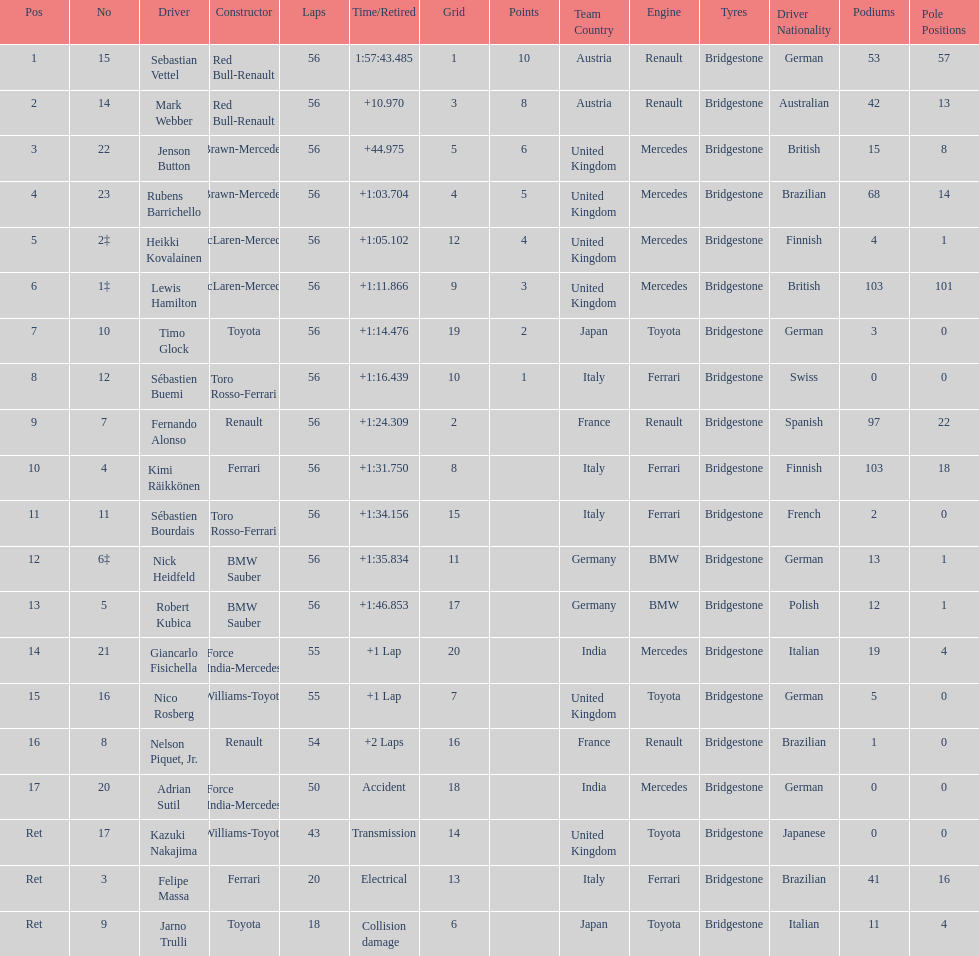Which driver is the only driver who retired because of collision damage? Jarno Trulli. 